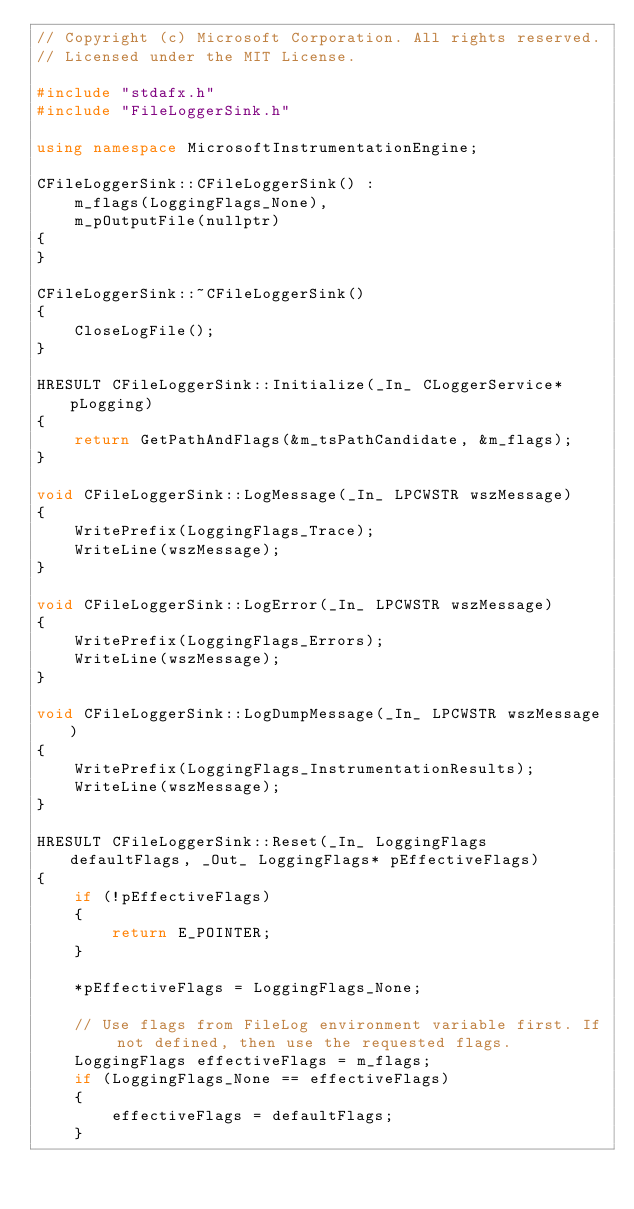Convert code to text. <code><loc_0><loc_0><loc_500><loc_500><_C++_>// Copyright (c) Microsoft Corporation. All rights reserved.
// Licensed under the MIT License.

#include "stdafx.h"
#include "FileLoggerSink.h"

using namespace MicrosoftInstrumentationEngine;

CFileLoggerSink::CFileLoggerSink() :
    m_flags(LoggingFlags_None),
    m_pOutputFile(nullptr)
{
}

CFileLoggerSink::~CFileLoggerSink()
{
    CloseLogFile();
}

HRESULT CFileLoggerSink::Initialize(_In_ CLoggerService* pLogging)
{
    return GetPathAndFlags(&m_tsPathCandidate, &m_flags);
}

void CFileLoggerSink::LogMessage(_In_ LPCWSTR wszMessage)
{
    WritePrefix(LoggingFlags_Trace);
    WriteLine(wszMessage);
}

void CFileLoggerSink::LogError(_In_ LPCWSTR wszMessage)
{
    WritePrefix(LoggingFlags_Errors);
    WriteLine(wszMessage);
}

void CFileLoggerSink::LogDumpMessage(_In_ LPCWSTR wszMessage)
{
    WritePrefix(LoggingFlags_InstrumentationResults);
    WriteLine(wszMessage);
}

HRESULT CFileLoggerSink::Reset(_In_ LoggingFlags defaultFlags, _Out_ LoggingFlags* pEffectiveFlags)
{
    if (!pEffectiveFlags)
    {
        return E_POINTER;
    }

    *pEffectiveFlags = LoggingFlags_None;

    // Use flags from FileLog environment variable first. If not defined, then use the requested flags.
    LoggingFlags effectiveFlags = m_flags;
    if (LoggingFlags_None == effectiveFlags)
    {
        effectiveFlags = defaultFlags;
    }
</code> 